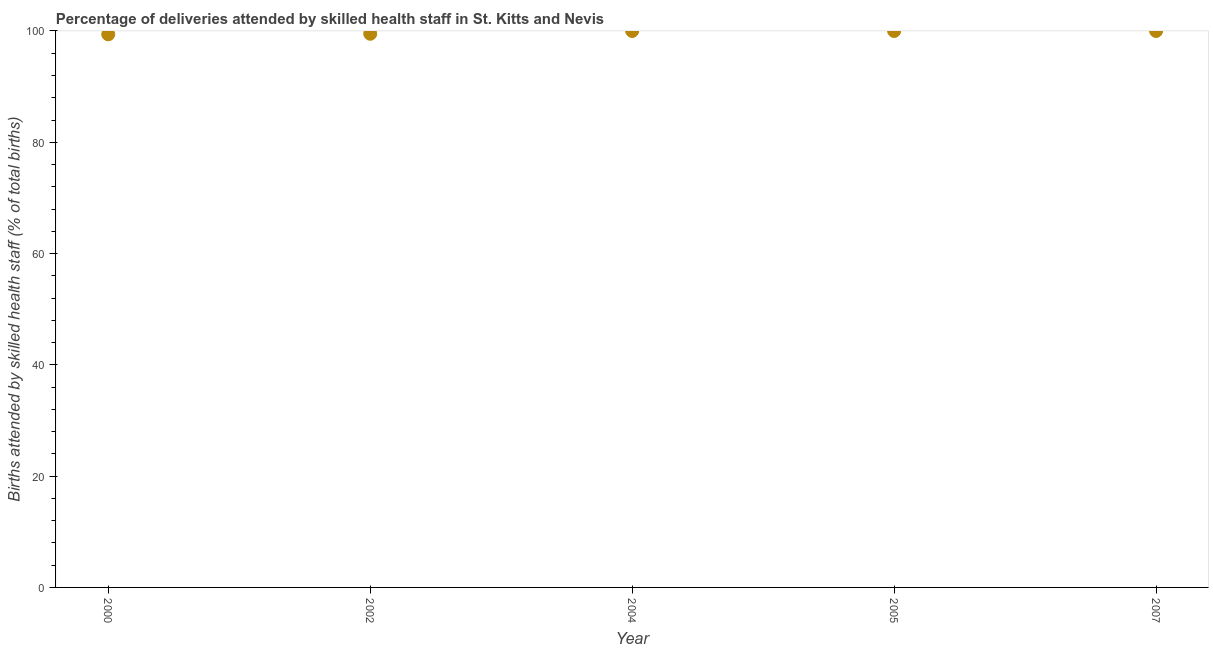Across all years, what is the maximum number of births attended by skilled health staff?
Make the answer very short. 100. Across all years, what is the minimum number of births attended by skilled health staff?
Keep it short and to the point. 99.4. In which year was the number of births attended by skilled health staff maximum?
Provide a short and direct response. 2004. What is the sum of the number of births attended by skilled health staff?
Your answer should be compact. 498.9. What is the difference between the number of births attended by skilled health staff in 2005 and 2007?
Provide a succinct answer. 0. What is the average number of births attended by skilled health staff per year?
Ensure brevity in your answer.  99.78. Do a majority of the years between 2002 and 2004 (inclusive) have number of births attended by skilled health staff greater than 56 %?
Make the answer very short. Yes. What is the ratio of the number of births attended by skilled health staff in 2000 to that in 2007?
Provide a succinct answer. 0.99. Is the number of births attended by skilled health staff in 2000 less than that in 2005?
Provide a short and direct response. Yes. Is the sum of the number of births attended by skilled health staff in 2000 and 2004 greater than the maximum number of births attended by skilled health staff across all years?
Provide a succinct answer. Yes. What is the difference between the highest and the lowest number of births attended by skilled health staff?
Your answer should be very brief. 0.6. In how many years, is the number of births attended by skilled health staff greater than the average number of births attended by skilled health staff taken over all years?
Make the answer very short. 3. Are the values on the major ticks of Y-axis written in scientific E-notation?
Offer a very short reply. No. What is the title of the graph?
Make the answer very short. Percentage of deliveries attended by skilled health staff in St. Kitts and Nevis. What is the label or title of the Y-axis?
Keep it short and to the point. Births attended by skilled health staff (% of total births). What is the Births attended by skilled health staff (% of total births) in 2000?
Provide a short and direct response. 99.4. What is the Births attended by skilled health staff (% of total births) in 2002?
Give a very brief answer. 99.5. What is the Births attended by skilled health staff (% of total births) in 2004?
Provide a short and direct response. 100. What is the Births attended by skilled health staff (% of total births) in 2005?
Provide a short and direct response. 100. What is the Births attended by skilled health staff (% of total births) in 2007?
Your answer should be very brief. 100. What is the difference between the Births attended by skilled health staff (% of total births) in 2000 and 2002?
Your response must be concise. -0.1. What is the difference between the Births attended by skilled health staff (% of total births) in 2000 and 2004?
Your answer should be very brief. -0.6. What is the difference between the Births attended by skilled health staff (% of total births) in 2000 and 2005?
Make the answer very short. -0.6. What is the difference between the Births attended by skilled health staff (% of total births) in 2002 and 2005?
Provide a short and direct response. -0.5. What is the difference between the Births attended by skilled health staff (% of total births) in 2004 and 2005?
Your answer should be very brief. 0. What is the ratio of the Births attended by skilled health staff (% of total births) in 2000 to that in 2002?
Provide a short and direct response. 1. What is the ratio of the Births attended by skilled health staff (% of total births) in 2002 to that in 2004?
Provide a short and direct response. 0.99. What is the ratio of the Births attended by skilled health staff (% of total births) in 2002 to that in 2005?
Offer a terse response. 0.99. What is the ratio of the Births attended by skilled health staff (% of total births) in 2004 to that in 2005?
Make the answer very short. 1. What is the ratio of the Births attended by skilled health staff (% of total births) in 2004 to that in 2007?
Your answer should be very brief. 1. What is the ratio of the Births attended by skilled health staff (% of total births) in 2005 to that in 2007?
Make the answer very short. 1. 